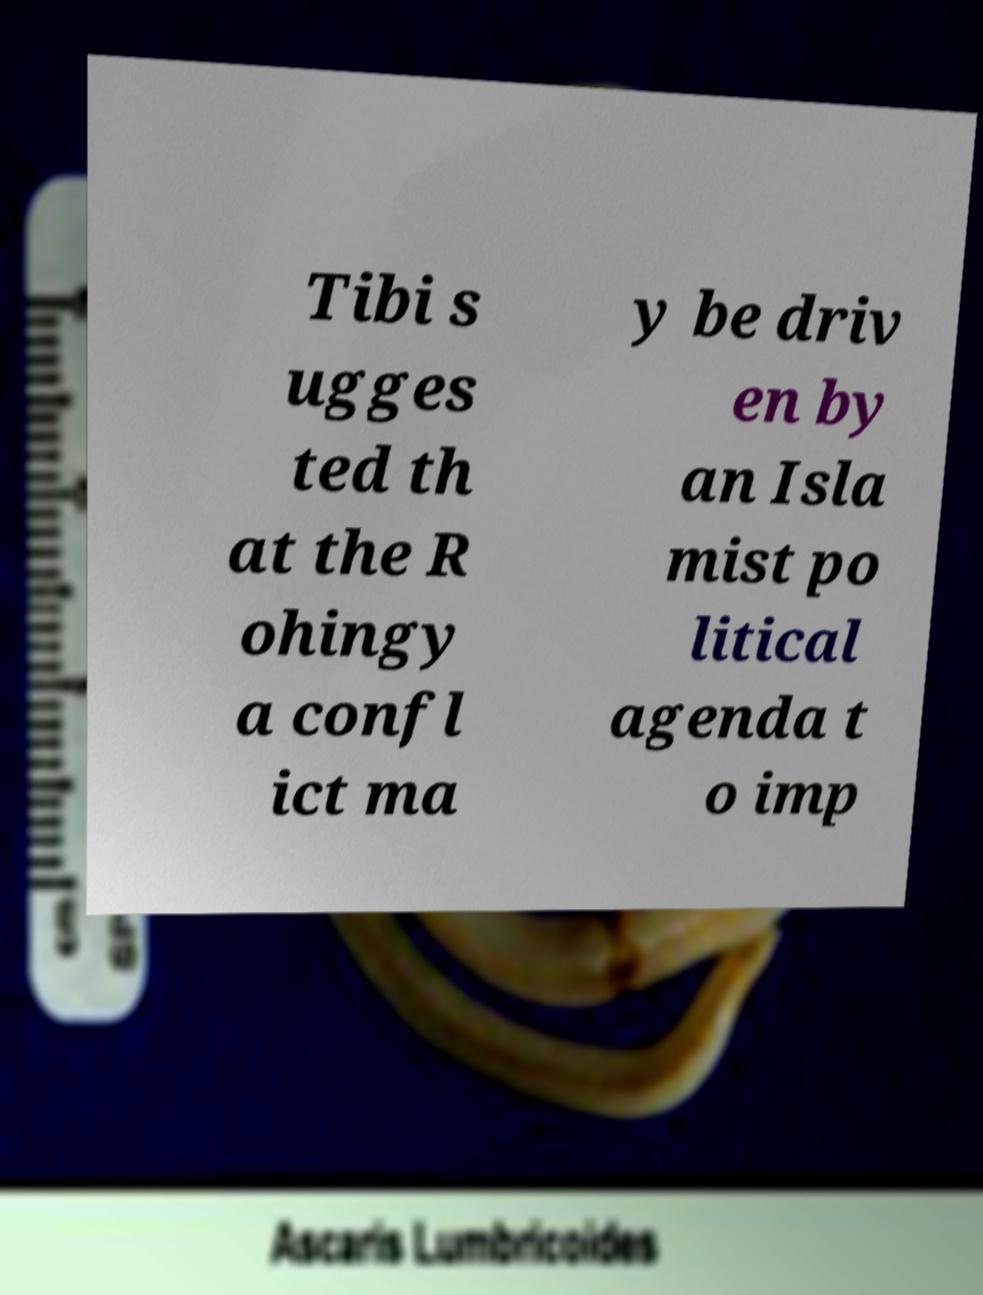Can you read and provide the text displayed in the image?This photo seems to have some interesting text. Can you extract and type it out for me? Tibi s ugges ted th at the R ohingy a confl ict ma y be driv en by an Isla mist po litical agenda t o imp 